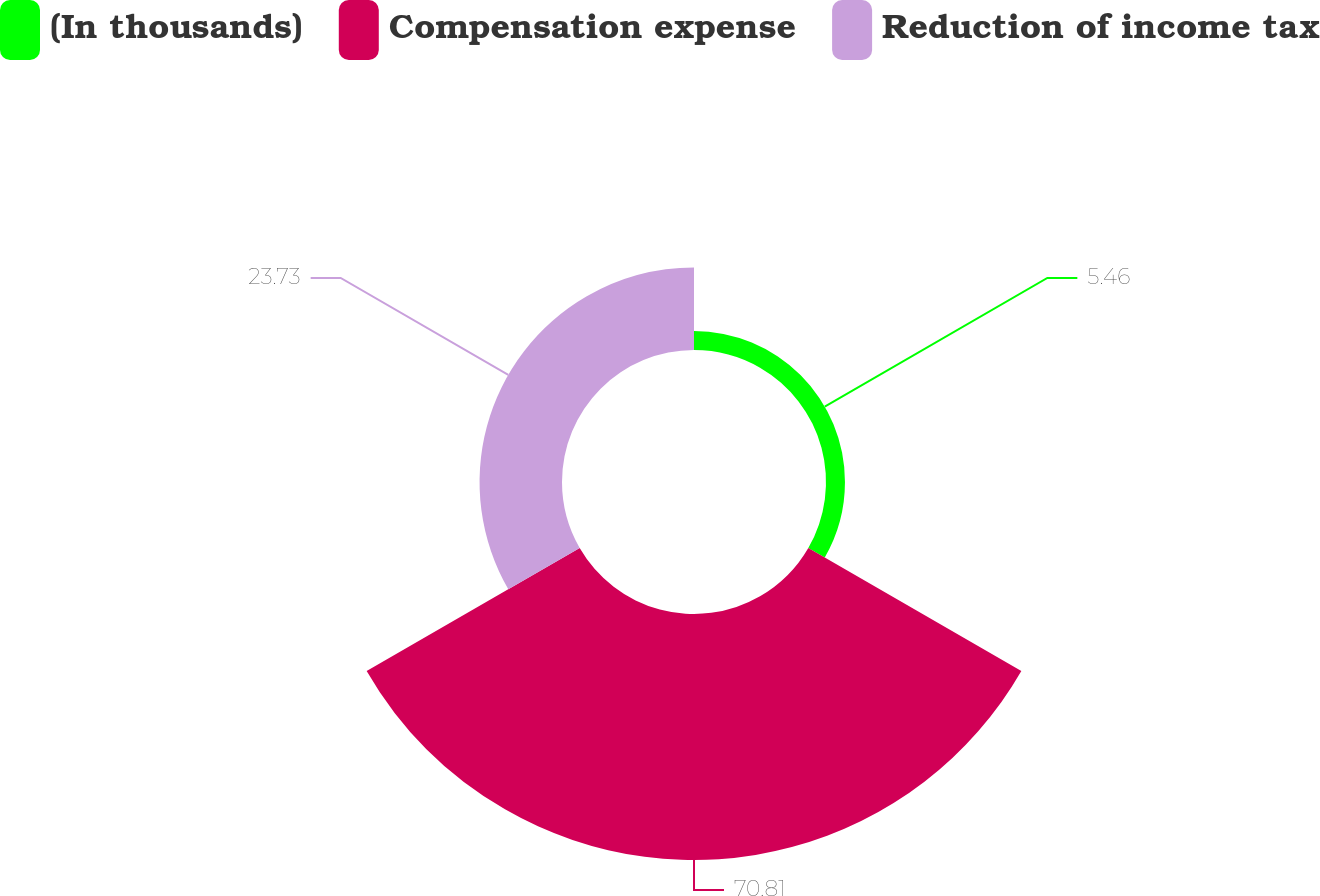Convert chart. <chart><loc_0><loc_0><loc_500><loc_500><pie_chart><fcel>(In thousands)<fcel>Compensation expense<fcel>Reduction of income tax<nl><fcel>5.46%<fcel>70.81%<fcel>23.73%<nl></chart> 